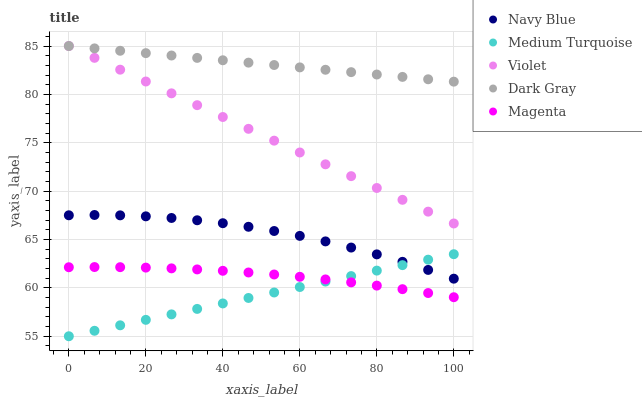Does Medium Turquoise have the minimum area under the curve?
Answer yes or no. Yes. Does Dark Gray have the maximum area under the curve?
Answer yes or no. Yes. Does Navy Blue have the minimum area under the curve?
Answer yes or no. No. Does Navy Blue have the maximum area under the curve?
Answer yes or no. No. Is Medium Turquoise the smoothest?
Answer yes or no. Yes. Is Navy Blue the roughest?
Answer yes or no. Yes. Is Magenta the smoothest?
Answer yes or no. No. Is Magenta the roughest?
Answer yes or no. No. Does Medium Turquoise have the lowest value?
Answer yes or no. Yes. Does Navy Blue have the lowest value?
Answer yes or no. No. Does Violet have the highest value?
Answer yes or no. Yes. Does Navy Blue have the highest value?
Answer yes or no. No. Is Medium Turquoise less than Dark Gray?
Answer yes or no. Yes. Is Violet greater than Magenta?
Answer yes or no. Yes. Does Violet intersect Dark Gray?
Answer yes or no. Yes. Is Violet less than Dark Gray?
Answer yes or no. No. Is Violet greater than Dark Gray?
Answer yes or no. No. Does Medium Turquoise intersect Dark Gray?
Answer yes or no. No. 